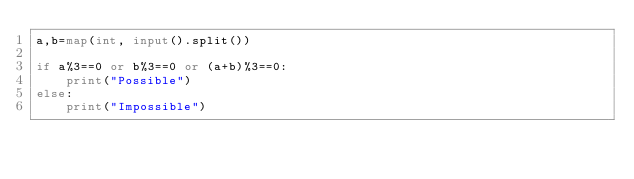<code> <loc_0><loc_0><loc_500><loc_500><_Python_>a,b=map(int, input().split())

if a%3==0 or b%3==0 or (a+b)%3==0:
    print("Possible")
else:
    print("Impossible")
</code> 